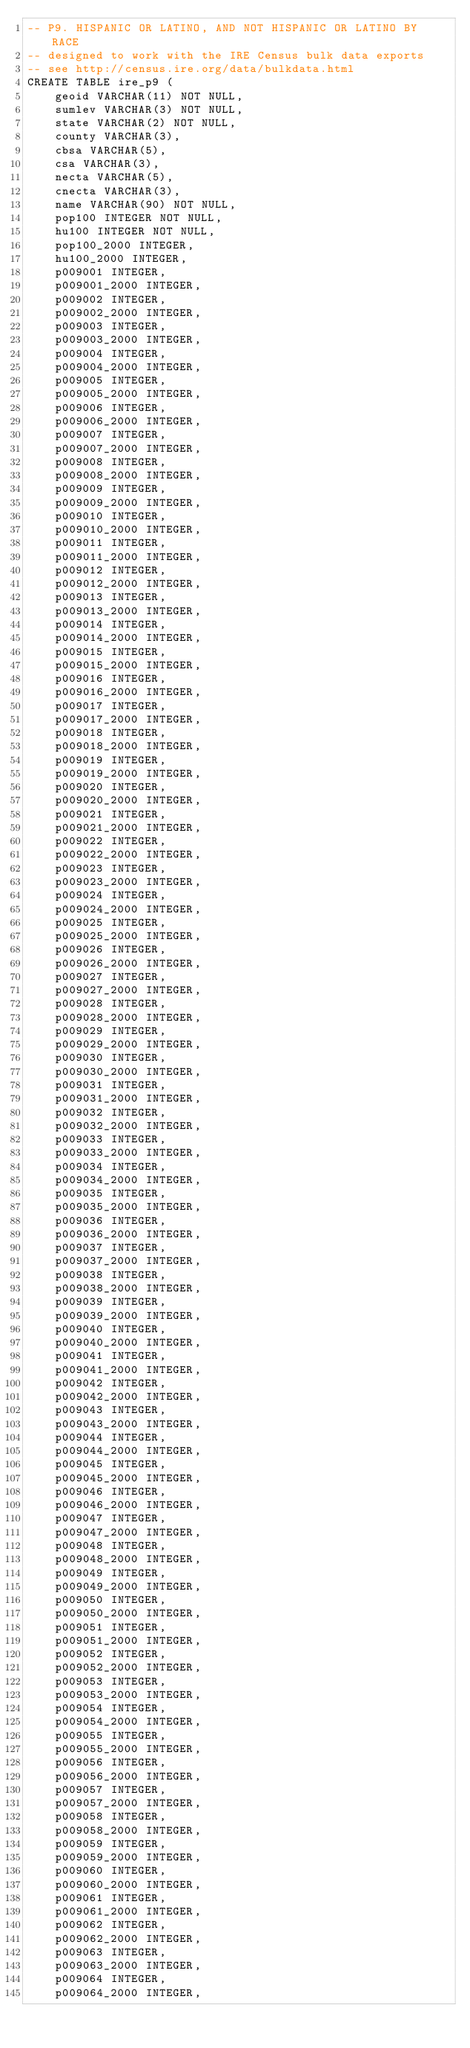Convert code to text. <code><loc_0><loc_0><loc_500><loc_500><_SQL_>-- P9. HISPANIC OR LATINO, AND NOT HISPANIC OR LATINO BY RACE
-- designed to work with the IRE Census bulk data exports
-- see http://census.ire.org/data/bulkdata.html
CREATE TABLE ire_p9 (
	geoid VARCHAR(11) NOT NULL, 
	sumlev VARCHAR(3) NOT NULL, 
	state VARCHAR(2) NOT NULL, 
	county VARCHAR(3), 
	cbsa VARCHAR(5), 
	csa VARCHAR(3), 
	necta VARCHAR(5), 
	cnecta VARCHAR(3), 
	name VARCHAR(90) NOT NULL, 
	pop100 INTEGER NOT NULL, 
	hu100 INTEGER NOT NULL, 
	pop100_2000 INTEGER, 
	hu100_2000 INTEGER, 
	p009001 INTEGER, 
	p009001_2000 INTEGER, 
	p009002 INTEGER, 
	p009002_2000 INTEGER, 
	p009003 INTEGER, 
	p009003_2000 INTEGER, 
	p009004 INTEGER, 
	p009004_2000 INTEGER, 
	p009005 INTEGER, 
	p009005_2000 INTEGER, 
	p009006 INTEGER, 
	p009006_2000 INTEGER, 
	p009007 INTEGER, 
	p009007_2000 INTEGER, 
	p009008 INTEGER, 
	p009008_2000 INTEGER, 
	p009009 INTEGER, 
	p009009_2000 INTEGER, 
	p009010 INTEGER, 
	p009010_2000 INTEGER, 
	p009011 INTEGER, 
	p009011_2000 INTEGER, 
	p009012 INTEGER, 
	p009012_2000 INTEGER, 
	p009013 INTEGER, 
	p009013_2000 INTEGER, 
	p009014 INTEGER, 
	p009014_2000 INTEGER, 
	p009015 INTEGER, 
	p009015_2000 INTEGER, 
	p009016 INTEGER, 
	p009016_2000 INTEGER, 
	p009017 INTEGER, 
	p009017_2000 INTEGER, 
	p009018 INTEGER, 
	p009018_2000 INTEGER, 
	p009019 INTEGER, 
	p009019_2000 INTEGER, 
	p009020 INTEGER, 
	p009020_2000 INTEGER, 
	p009021 INTEGER, 
	p009021_2000 INTEGER, 
	p009022 INTEGER, 
	p009022_2000 INTEGER, 
	p009023 INTEGER, 
	p009023_2000 INTEGER, 
	p009024 INTEGER, 
	p009024_2000 INTEGER, 
	p009025 INTEGER, 
	p009025_2000 INTEGER, 
	p009026 INTEGER, 
	p009026_2000 INTEGER, 
	p009027 INTEGER, 
	p009027_2000 INTEGER, 
	p009028 INTEGER, 
	p009028_2000 INTEGER, 
	p009029 INTEGER, 
	p009029_2000 INTEGER, 
	p009030 INTEGER, 
	p009030_2000 INTEGER, 
	p009031 INTEGER, 
	p009031_2000 INTEGER, 
	p009032 INTEGER, 
	p009032_2000 INTEGER, 
	p009033 INTEGER, 
	p009033_2000 INTEGER, 
	p009034 INTEGER, 
	p009034_2000 INTEGER, 
	p009035 INTEGER, 
	p009035_2000 INTEGER, 
	p009036 INTEGER, 
	p009036_2000 INTEGER, 
	p009037 INTEGER, 
	p009037_2000 INTEGER, 
	p009038 INTEGER, 
	p009038_2000 INTEGER, 
	p009039 INTEGER, 
	p009039_2000 INTEGER, 
	p009040 INTEGER, 
	p009040_2000 INTEGER, 
	p009041 INTEGER, 
	p009041_2000 INTEGER, 
	p009042 INTEGER, 
	p009042_2000 INTEGER, 
	p009043 INTEGER, 
	p009043_2000 INTEGER, 
	p009044 INTEGER, 
	p009044_2000 INTEGER, 
	p009045 INTEGER, 
	p009045_2000 INTEGER, 
	p009046 INTEGER, 
	p009046_2000 INTEGER, 
	p009047 INTEGER, 
	p009047_2000 INTEGER, 
	p009048 INTEGER, 
	p009048_2000 INTEGER, 
	p009049 INTEGER, 
	p009049_2000 INTEGER, 
	p009050 INTEGER, 
	p009050_2000 INTEGER, 
	p009051 INTEGER, 
	p009051_2000 INTEGER, 
	p009052 INTEGER, 
	p009052_2000 INTEGER, 
	p009053 INTEGER, 
	p009053_2000 INTEGER, 
	p009054 INTEGER, 
	p009054_2000 INTEGER, 
	p009055 INTEGER, 
	p009055_2000 INTEGER, 
	p009056 INTEGER, 
	p009056_2000 INTEGER, 
	p009057 INTEGER, 
	p009057_2000 INTEGER, 
	p009058 INTEGER, 
	p009058_2000 INTEGER, 
	p009059 INTEGER, 
	p009059_2000 INTEGER, 
	p009060 INTEGER, 
	p009060_2000 INTEGER, 
	p009061 INTEGER, 
	p009061_2000 INTEGER, 
	p009062 INTEGER, 
	p009062_2000 INTEGER, 
	p009063 INTEGER, 
	p009063_2000 INTEGER, 
	p009064 INTEGER, 
	p009064_2000 INTEGER, </code> 